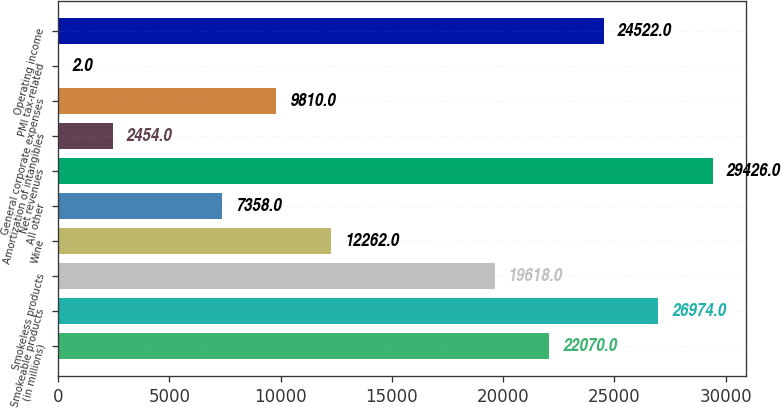Convert chart to OTSL. <chart><loc_0><loc_0><loc_500><loc_500><bar_chart><fcel>(in millions)<fcel>Smokeable products<fcel>Smokeless products<fcel>Wine<fcel>All other<fcel>Net revenues<fcel>Amortization of intangibles<fcel>General corporate expenses<fcel>PMI tax-related<fcel>Operating income<nl><fcel>22070<fcel>26974<fcel>19618<fcel>12262<fcel>7358<fcel>29426<fcel>2454<fcel>9810<fcel>2<fcel>24522<nl></chart> 